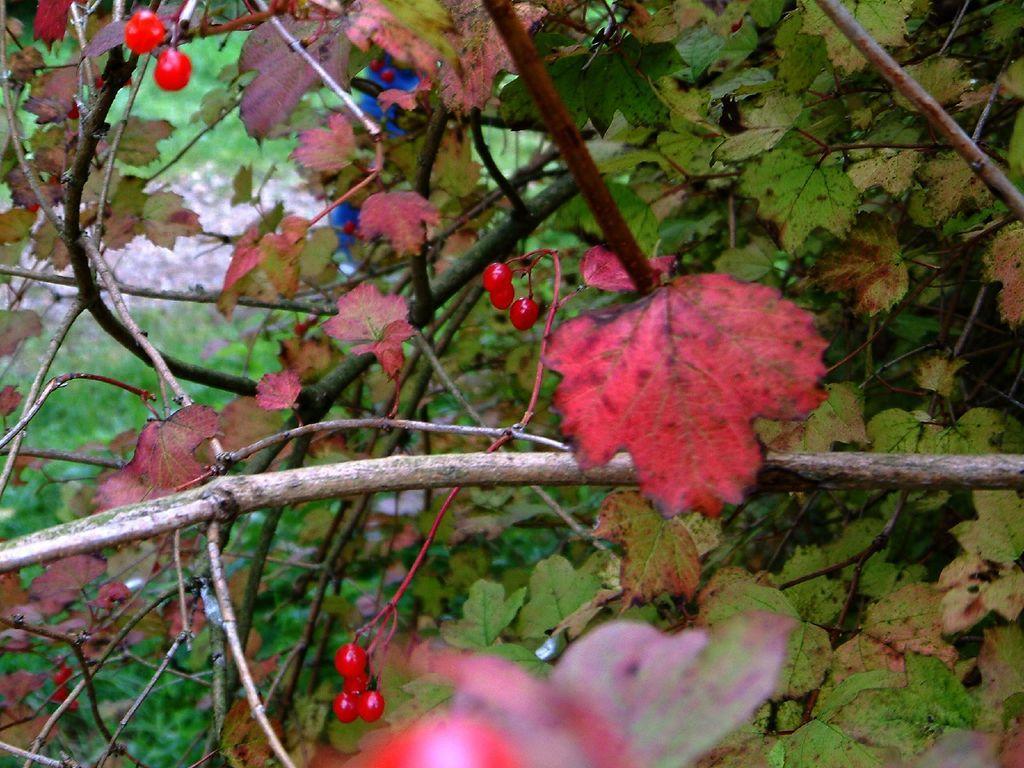Please provide a concise description of this image. In this picture I can see the plants. 